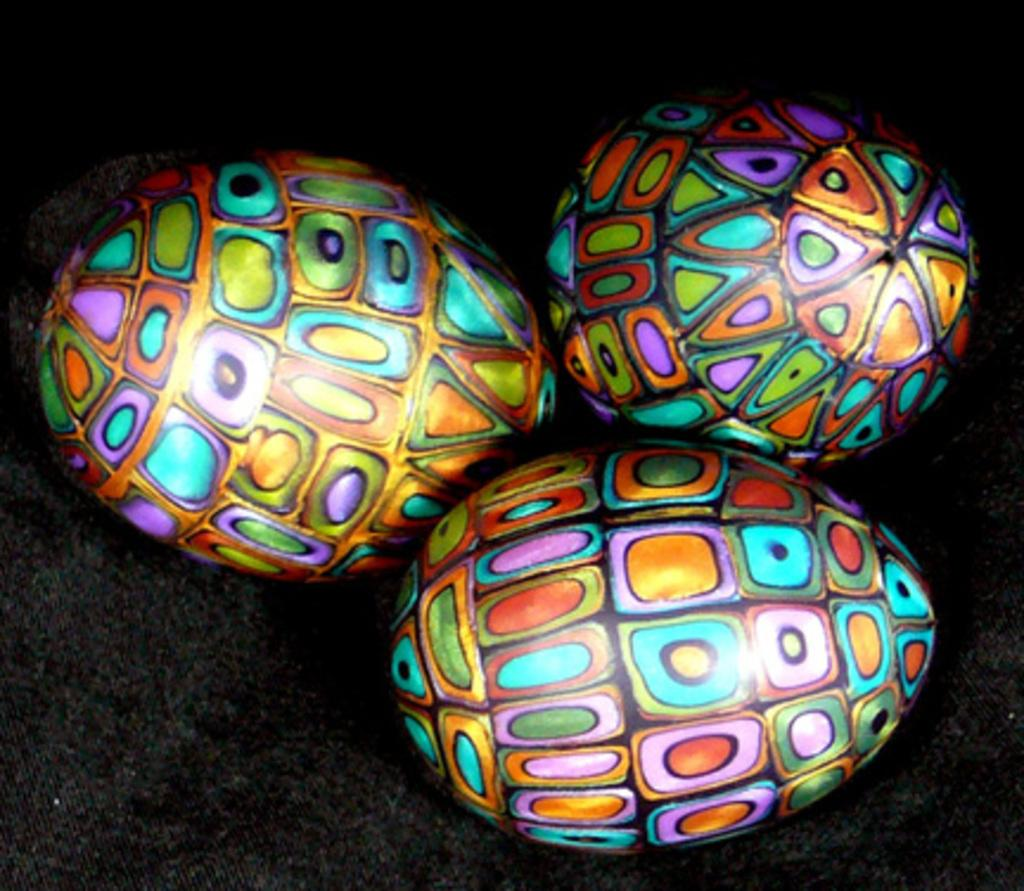What shapes are the balls in the image? The balls in the image are oval-shaped. How many balls are there in the image? There are three balls in the image. What can be observed about the colors of the balls? The balls are painted with different colors. What is the surface on which the balls are placed? The balls are placed on a black surface. Can you tell me how many horses are helping to move the balls in the image? There are no horses present in the image, and the balls are stationary on the black surface. 